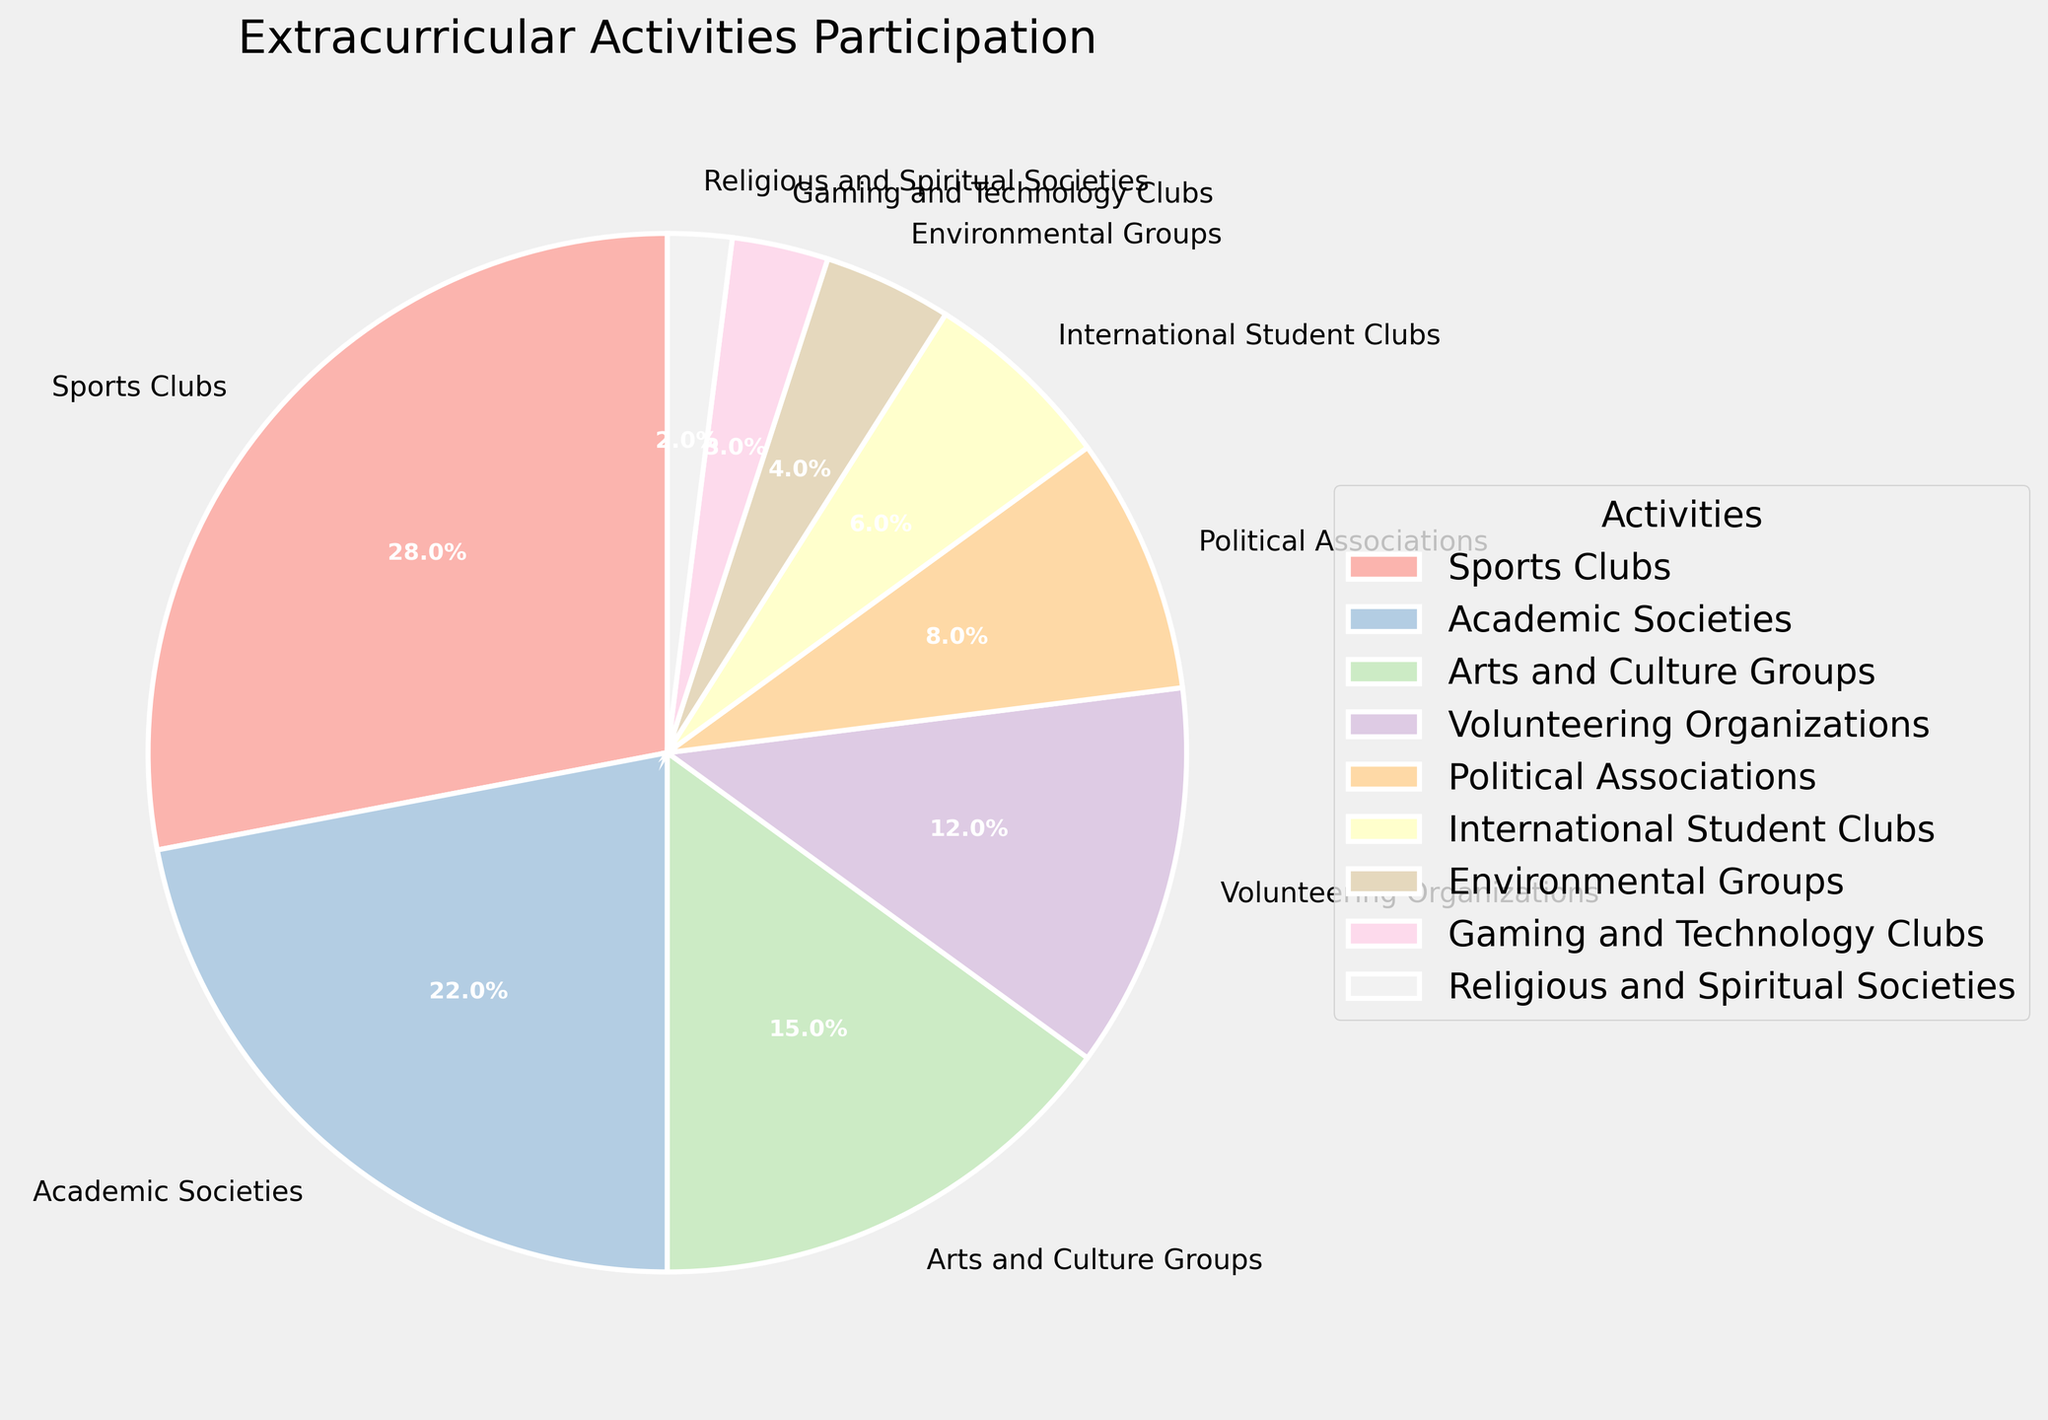What's the most popular extracurricular activity? By looking at the pie chart, we can see which activity has the largest wedge. The sports clubs slice is the largest, indicating that it has the highest participation percentage.
Answer: Sports Clubs Compare the participation rate of Academic Societies and Arts and Culture Groups. Which one is higher? Observing the size of the slices, we compare the Academic Societies (22%) to the Arts and Culture Groups (15%). The slice for Academic Societies is larger.
Answer: Academic Societies What is the combined participation percentage of Volunteering Organizations, Political Associations, and International Student Clubs? We add up their percentages: Volunteering Organizations (12%) + Political Associations (8%) + International Student Clubs (6%) = 12% + 8% + 6% = 26%.
Answer: 26% Which activity has the smallest wedge, and what is its participation percentage? By identifying the smallest slice on the pie chart, we see that Religious and Spiritual Societies have the smallest wedge with a participation percentage of 2%.
Answer: Religious and Spiritual Societies, 2% Is the participation in Environmental Groups higher than Gaming and Technology Clubs? Comparing the slices, Environmental Groups (4%) have a larger slice than Gaming and Technology Clubs (3%).
Answer: Yes What is the difference in participation percentage between Sports Clubs and Political Associations? We subtract the participation percentage of Political Associations (8%) from Sports Clubs (28%): 28% - 8% = 20%.
Answer: 20% Calculate the average participation percentage of Academic Societies, Arts and Culture Groups, and Volunteering Organizations. We sum their percentages and divide by the total number of groups: (22% + 15% + 12%) / 3 = 49% / 3 ≈ 16.33%.
Answer: 16.33% Which has a higher participation percentage: Environmental Groups or Religious and Spiritual Societies? Observing the slices, Environmental Groups have a participation percentage of 4%, while Religious and Spiritual Societies have 2%.
Answer: Environmental Groups What colors are used to represent Sports Clubs and Political Associations? The color representing Sports Clubs is typically a prominent, visible color in the pastel palette, while Political Associations would have a distinguishable different color in the same range. For instance, Sports Clubs might be a pastel red, and Political Associations a pastel orange.
Answer: Pastel colors - specific colors vary within the palette 